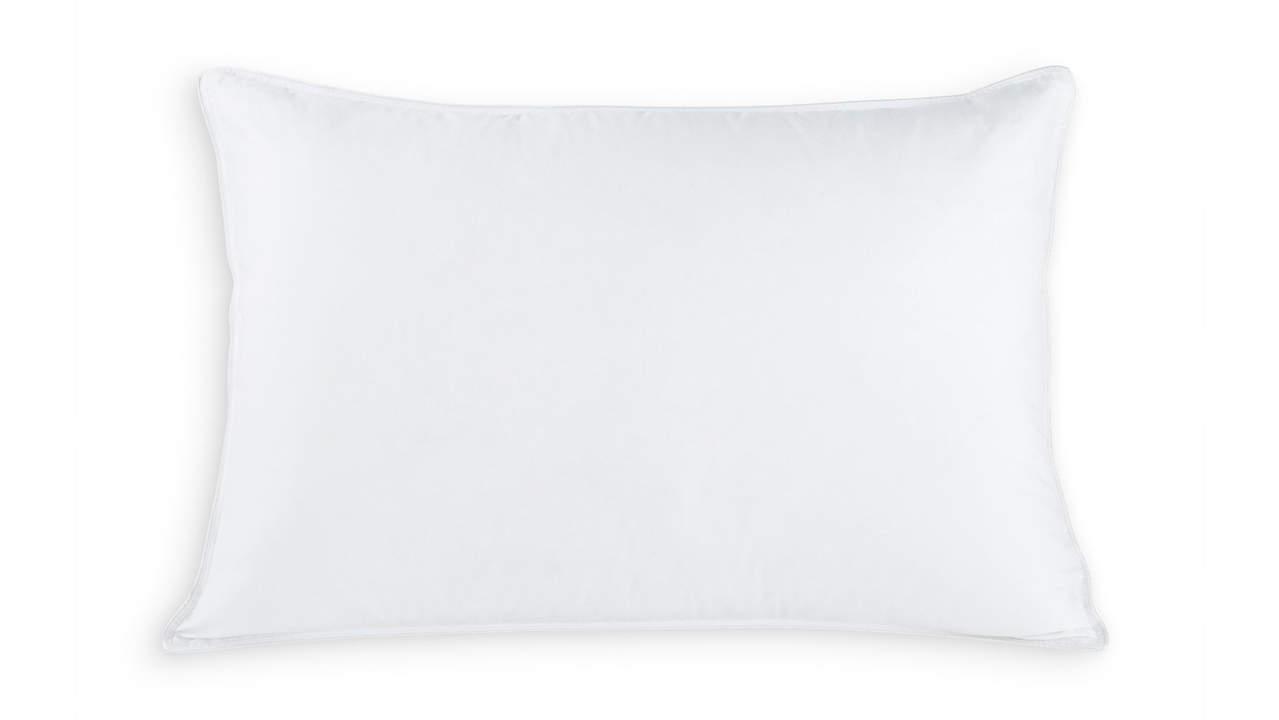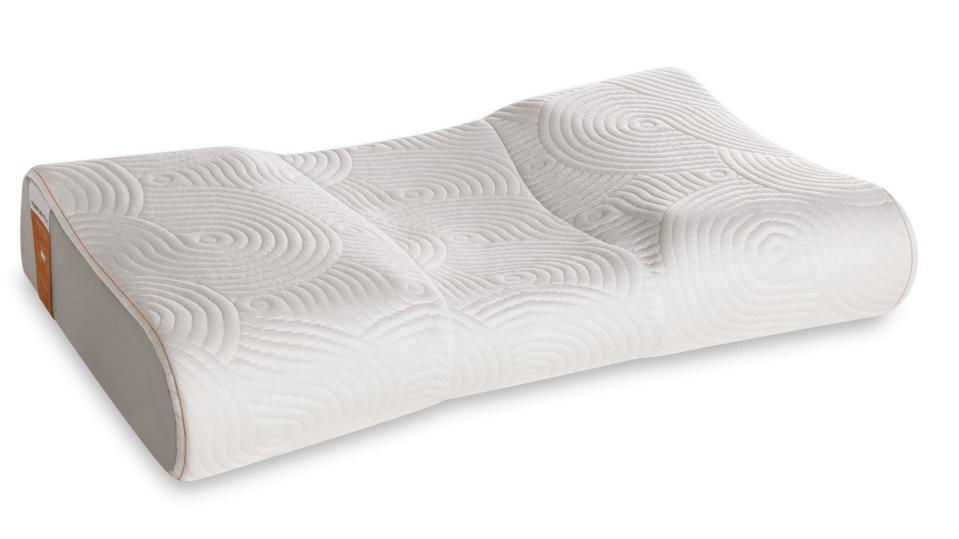The first image is the image on the left, the second image is the image on the right. For the images displayed, is the sentence "One image features a sculpted pillow style with a concave shape, and the other image features a pillow style with pointed corners." factually correct? Answer yes or no. Yes. The first image is the image on the left, the second image is the image on the right. For the images shown, is this caption "There are more pillows in the image on the right." true? Answer yes or no. No. 